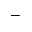Convert formula to latex. <formula><loc_0><loc_0><loc_500><loc_500>^ { - }</formula> 